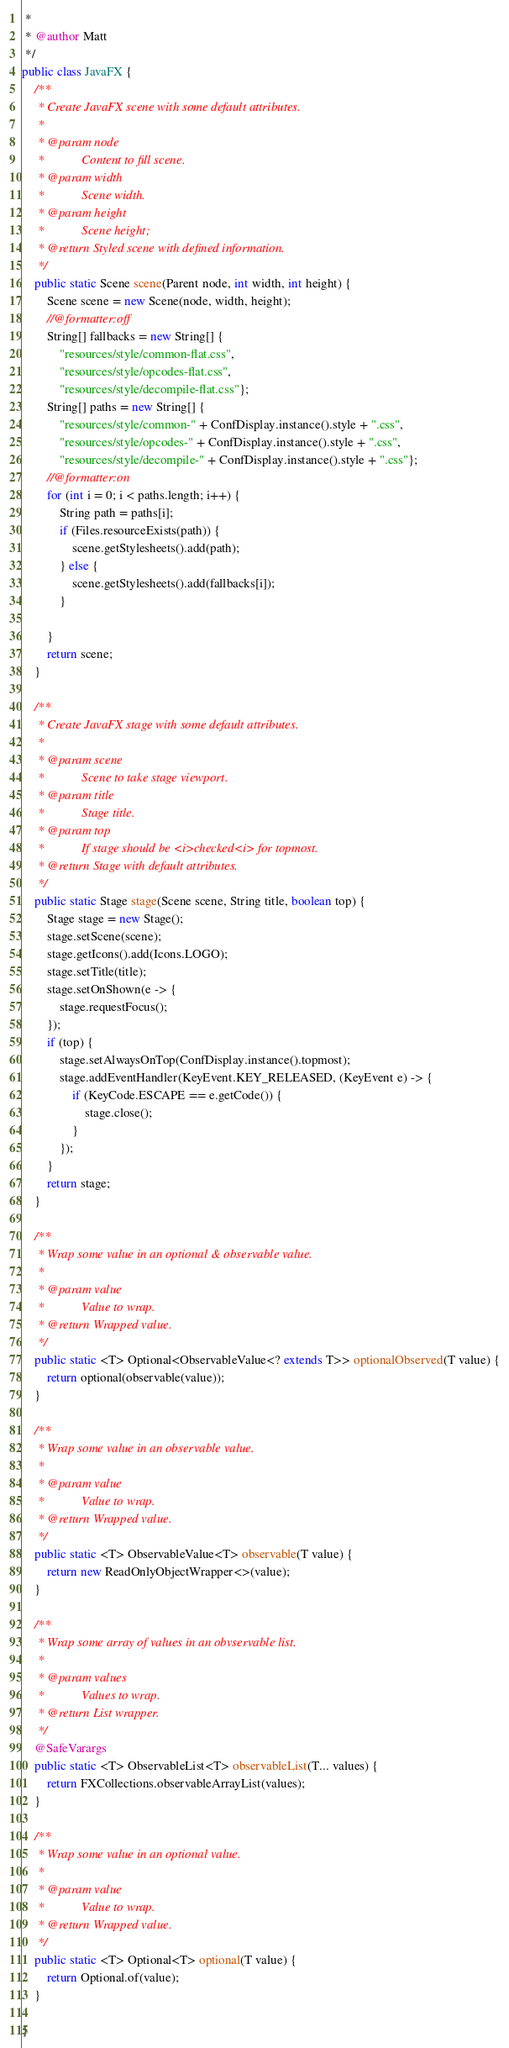<code> <loc_0><loc_0><loc_500><loc_500><_Java_> * 
 * @author Matt
 */
public class JavaFX {
	/**
	 * Create JavaFX scene with some default attributes.
	 * 
	 * @param node
	 *            Content to fill scene.
	 * @param width
	 *            Scene width.
	 * @param height
	 *            Scene height;
	 * @return Styled scene with defined information.
	 */
	public static Scene scene(Parent node, int width, int height) {
		Scene scene = new Scene(node, width, height);
		//@formatter:off
		String[] fallbacks = new String[] { 
			"resources/style/common-flat.css",
			"resources/style/opcodes-flat.css",
			"resources/style/decompile-flat.css"};
		String[] paths = new String[] { 
			"resources/style/common-" + ConfDisplay.instance().style + ".css",
			"resources/style/opcodes-" + ConfDisplay.instance().style + ".css",
			"resources/style/decompile-" + ConfDisplay.instance().style + ".css"};
		//@formatter:on
		for (int i = 0; i < paths.length; i++) { 
			String path = paths[i];
			if (Files.resourceExists(path)) {
				scene.getStylesheets().add(path);
			} else {
				scene.getStylesheets().add(fallbacks[i]);
			}

		}
		return scene;
	}

	/**
	 * Create JavaFX stage with some default attributes.
	 * 
	 * @param scene
	 *            Scene to take stage viewport.
	 * @param title
	 *            Stage title.
	 * @param top
	 *            If stage should be <i>checked<i> for topmost.
	 * @return Stage with default attributes.
	 */
	public static Stage stage(Scene scene, String title, boolean top) {
		Stage stage = new Stage();
		stage.setScene(scene);
		stage.getIcons().add(Icons.LOGO);
		stage.setTitle(title);
		stage.setOnShown(e -> {
			stage.requestFocus();
		});
		if (top) {
			stage.setAlwaysOnTop(ConfDisplay.instance().topmost);
			stage.addEventHandler(KeyEvent.KEY_RELEASED, (KeyEvent e) -> {
				if (KeyCode.ESCAPE == e.getCode()) {
					stage.close();
				}
			});
		}
		return stage;
	}

	/**
	 * Wrap some value in an optional & observable value.
	 * 
	 * @param value
	 *            Value to wrap.
	 * @return Wrapped value.
	 */
	public static <T> Optional<ObservableValue<? extends T>> optionalObserved(T value) {
		return optional(observable(value));
	}

	/**
	 * Wrap some value in an observable value.
	 * 
	 * @param value
	 *            Value to wrap.
	 * @return Wrapped value.
	 */
	public static <T> ObservableValue<T> observable(T value) {
		return new ReadOnlyObjectWrapper<>(value);
	}

	/**
	 * Wrap some array of values in an obvservable list.
	 * 
	 * @param values
	 *            Values to wrap.
	 * @return List wrapper.
	 */
	@SafeVarargs
	public static <T> ObservableList<T> observableList(T... values) {
		return FXCollections.observableArrayList(values);
	}

	/**
	 * Wrap some value in an optional value.
	 * 
	 * @param value
	 *            Value to wrap.
	 * @return Wrapped value.
	 */
	public static <T> Optional<T> optional(T value) {
		return Optional.of(value);
	}

}
</code> 